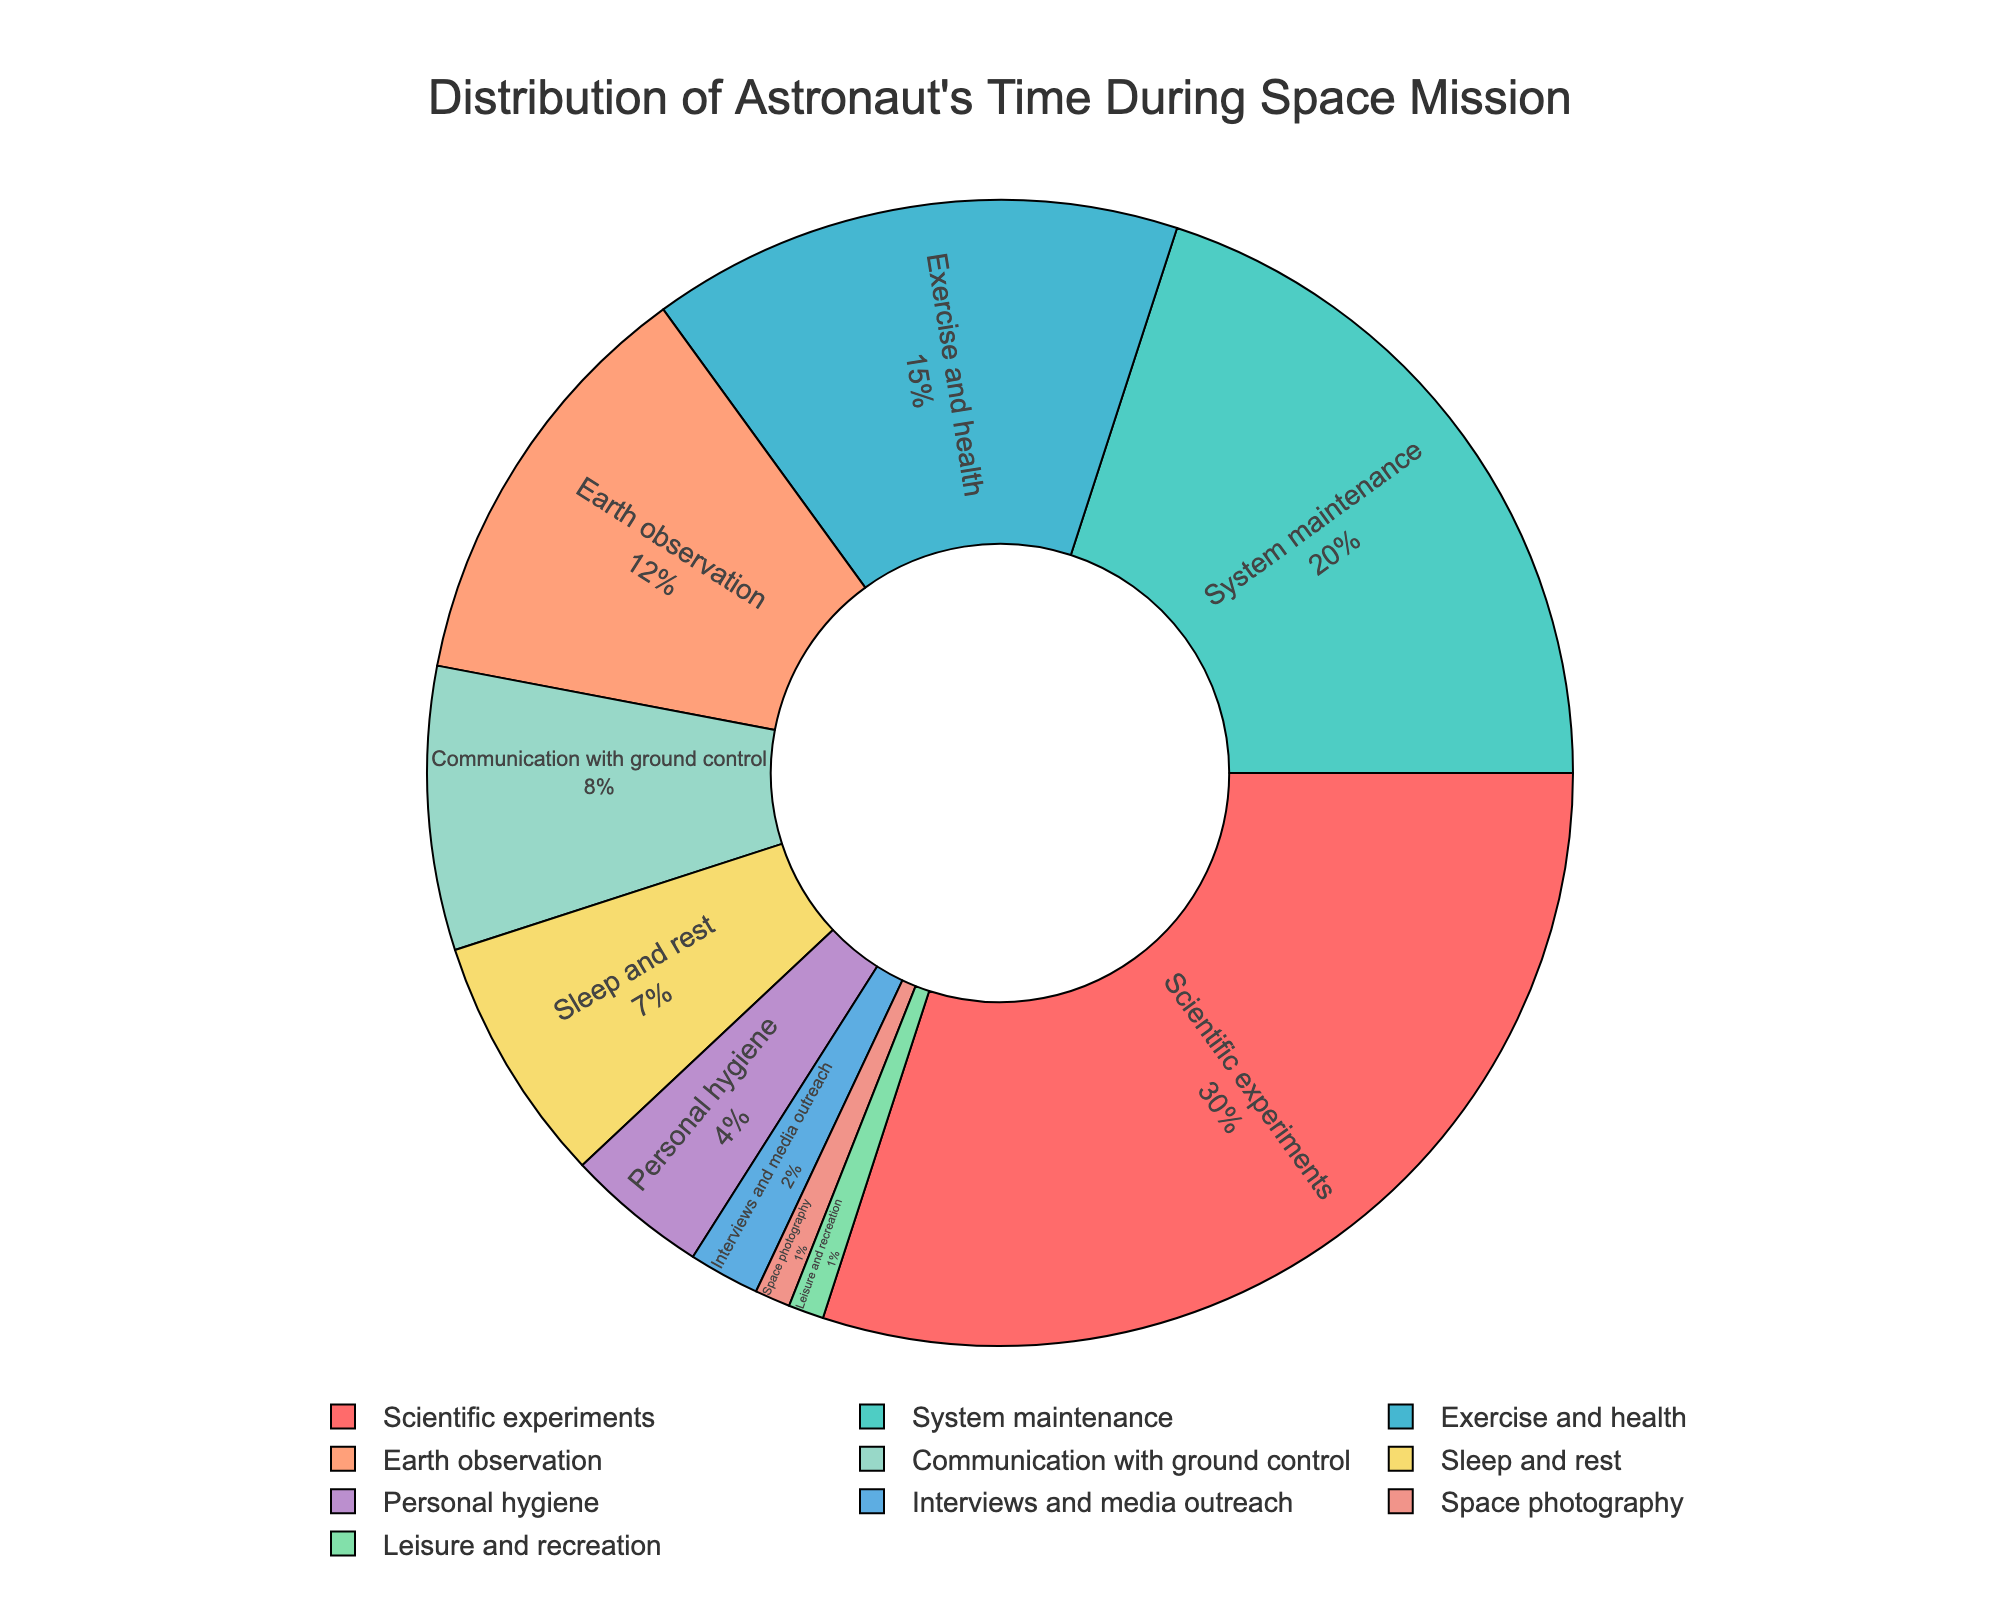what is the title of the pie chart? The title is located at the top of the figure, and it usually describes what the chart is about.
Answer: Distribution of Astronaut's Time During Space Mission What activity occupies the largest portion of the astronaut's time during a space mission? By examining the segments of the pie, the largest one is the most significant activity.
Answer: Scientific experiments How many different activities are represented in the pie chart? Count each unique segment of the pie chart to determine the total number of different activities.
Answer: 10 Which activity takes up more time, system maintenance or communication with ground control? Locate the segments for both activities and compare their proportions.
Answer: System maintenance What is the combined percentage of time spent on exercise and health, earth observation, and communication with ground control? Add up the percentages of the activities: 15% (exercise and health) + 12% (earth observation) + 8% (communication with ground control).
Answer: 35% Which activities take up less than 5% of the astronaut's time? Identify the segments with percentages smaller than 5%. These are Personal Hygiene, Interviews and media outreach, Space photography, and Leisure and recreation.
Answer: Personal hygiene, Interviews and media outreach, Space photography, Leisure and recreation Which category has the smallest time allocation, and what is its percentage? Locate the smallest segment and note its corresponding label and percentage.
Answer: Leisure and recreation, 1% Is the time spent on scientific experiments greater than the combined time spent on personal hygiene, interviews and media outreach, space photography, and leisure and recreation? Compare the percentage for scientific experiments (30%) with the sum of the percentages of the other activities (4% + 2% + 1% + 1%).
Answer: Yes How much more time is allocated to doing scientific experiments compared to exercising and maintaining health? Determine the difference between the percentages for scientific experiments and exercise and health: 30% - 15%.
Answer: 15% What activity associated with communication takes up more time, communicating with ground control or media outreach? Compare the segments for communication with ground control (8%) and interviews and media outreach (2%).
Answer: Communication with ground control 